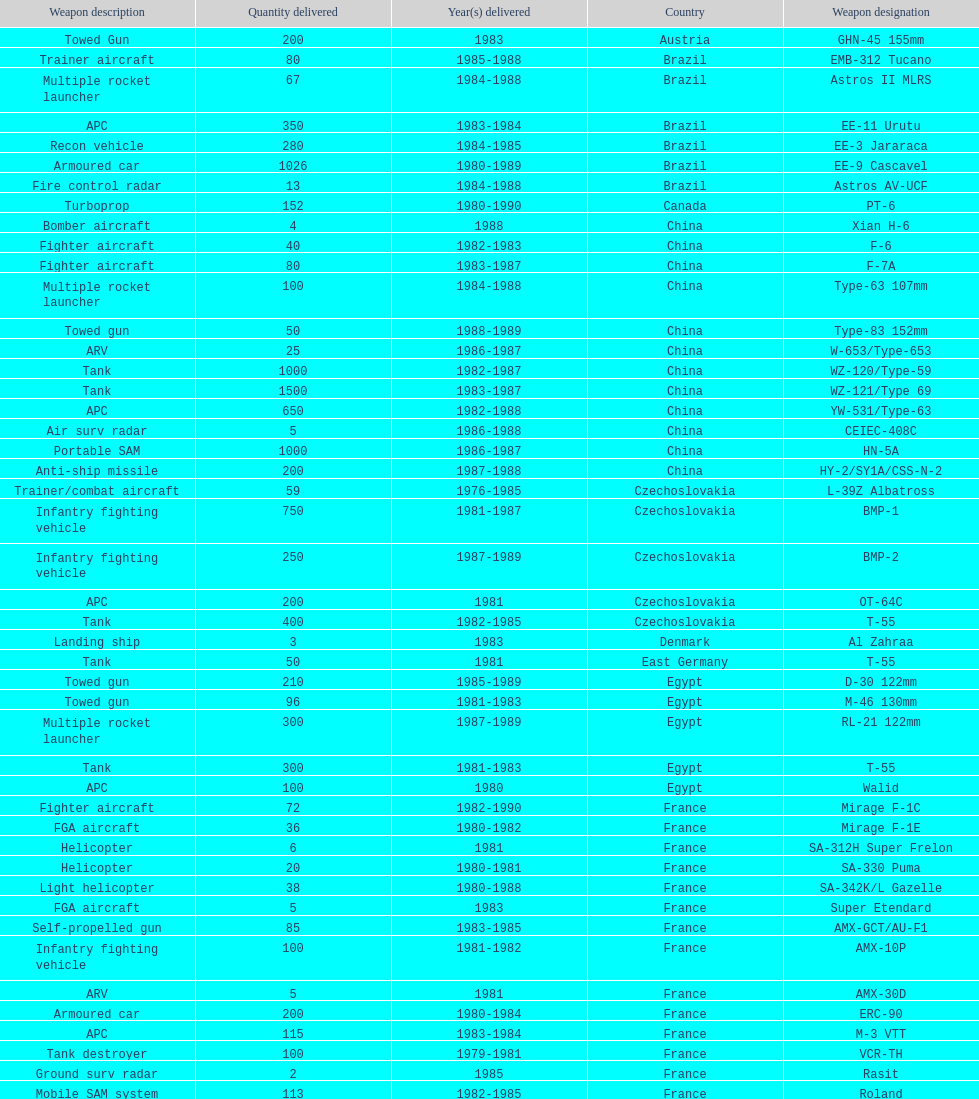Which country had the largest number of towed guns delivered? Soviet Union. 